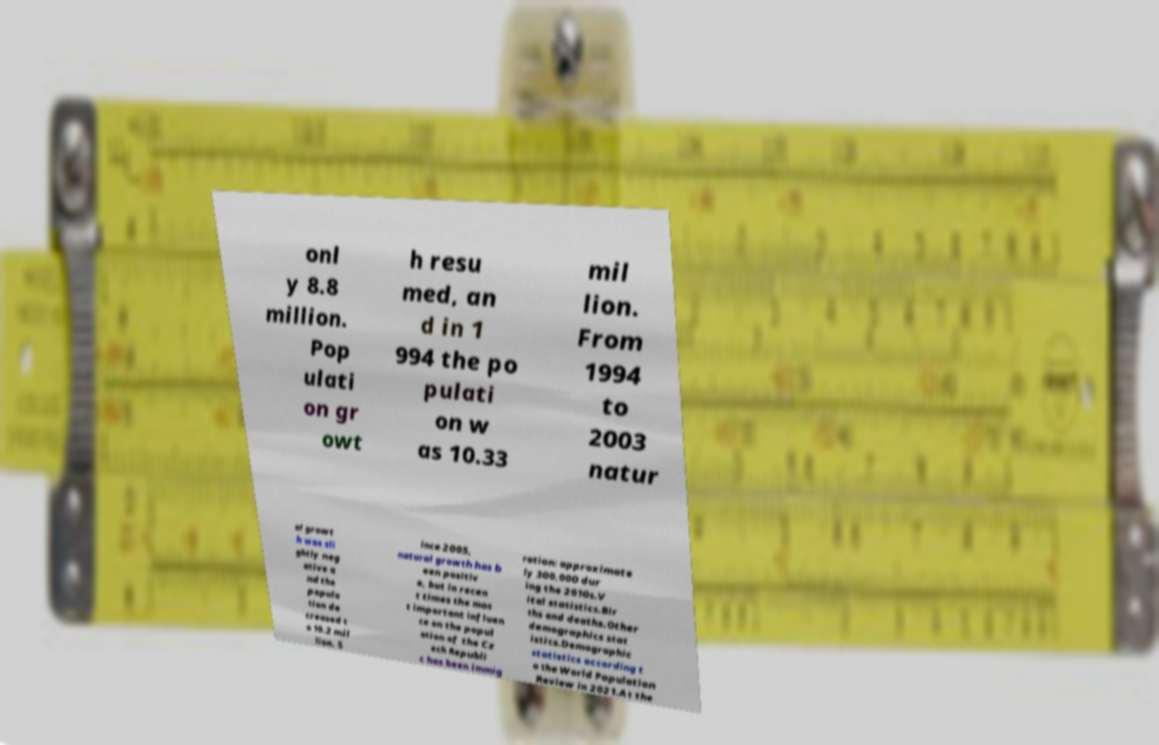Please identify and transcribe the text found in this image. onl y 8.8 million. Pop ulati on gr owt h resu med, an d in 1 994 the po pulati on w as 10.33 mil lion. From 1994 to 2003 natur al growt h was sli ghtly neg ative a nd the popula tion de creased t o 10.2 mil lion. S ince 2005, natural growth has b een positiv e, but in recen t times the mos t important influen ce on the popul ation of the Cz ech Republi c has been immig ration: approximate ly 300,000 dur ing the 2010s.V ital statistics.Bir ths and deaths.Other demographics stat istics.Demographic statistics according t o the World Population Review in 2021.At the 